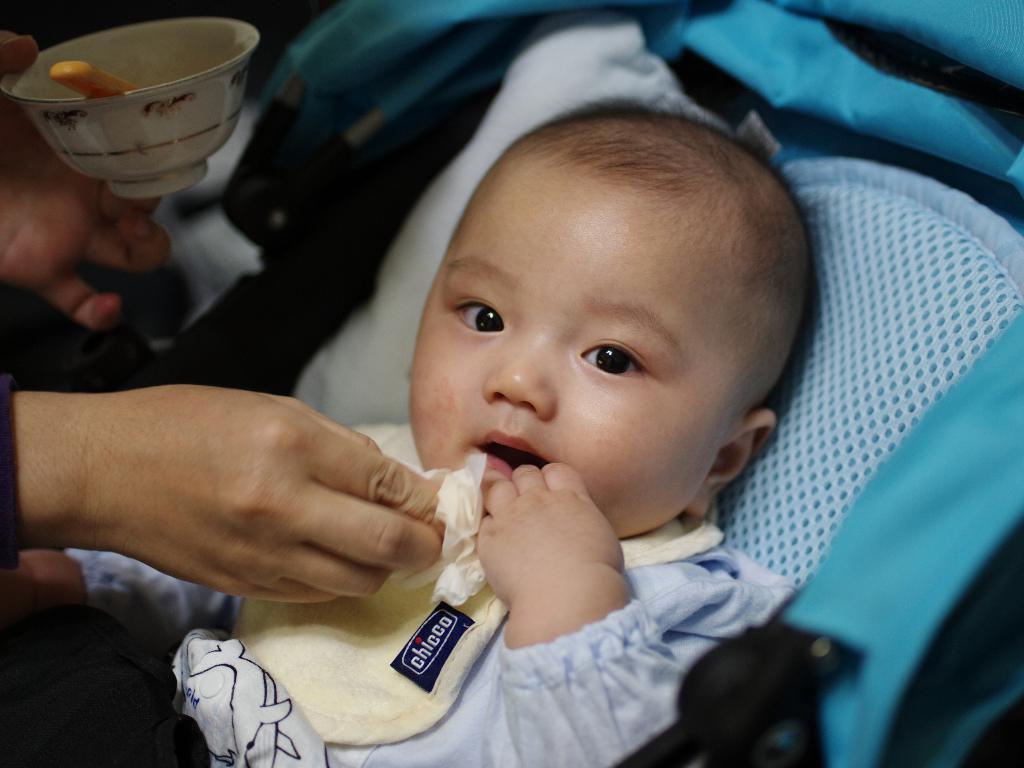How would you summarize this image in a sentence or two? In this picture, we see a baby in white dress is in the baby trolley. Here, we see a woman is wiping the mouth of the baby with the tissue paper and she is holding a white bowl and a spoon in her hand. This baby trolley is in blue color. 